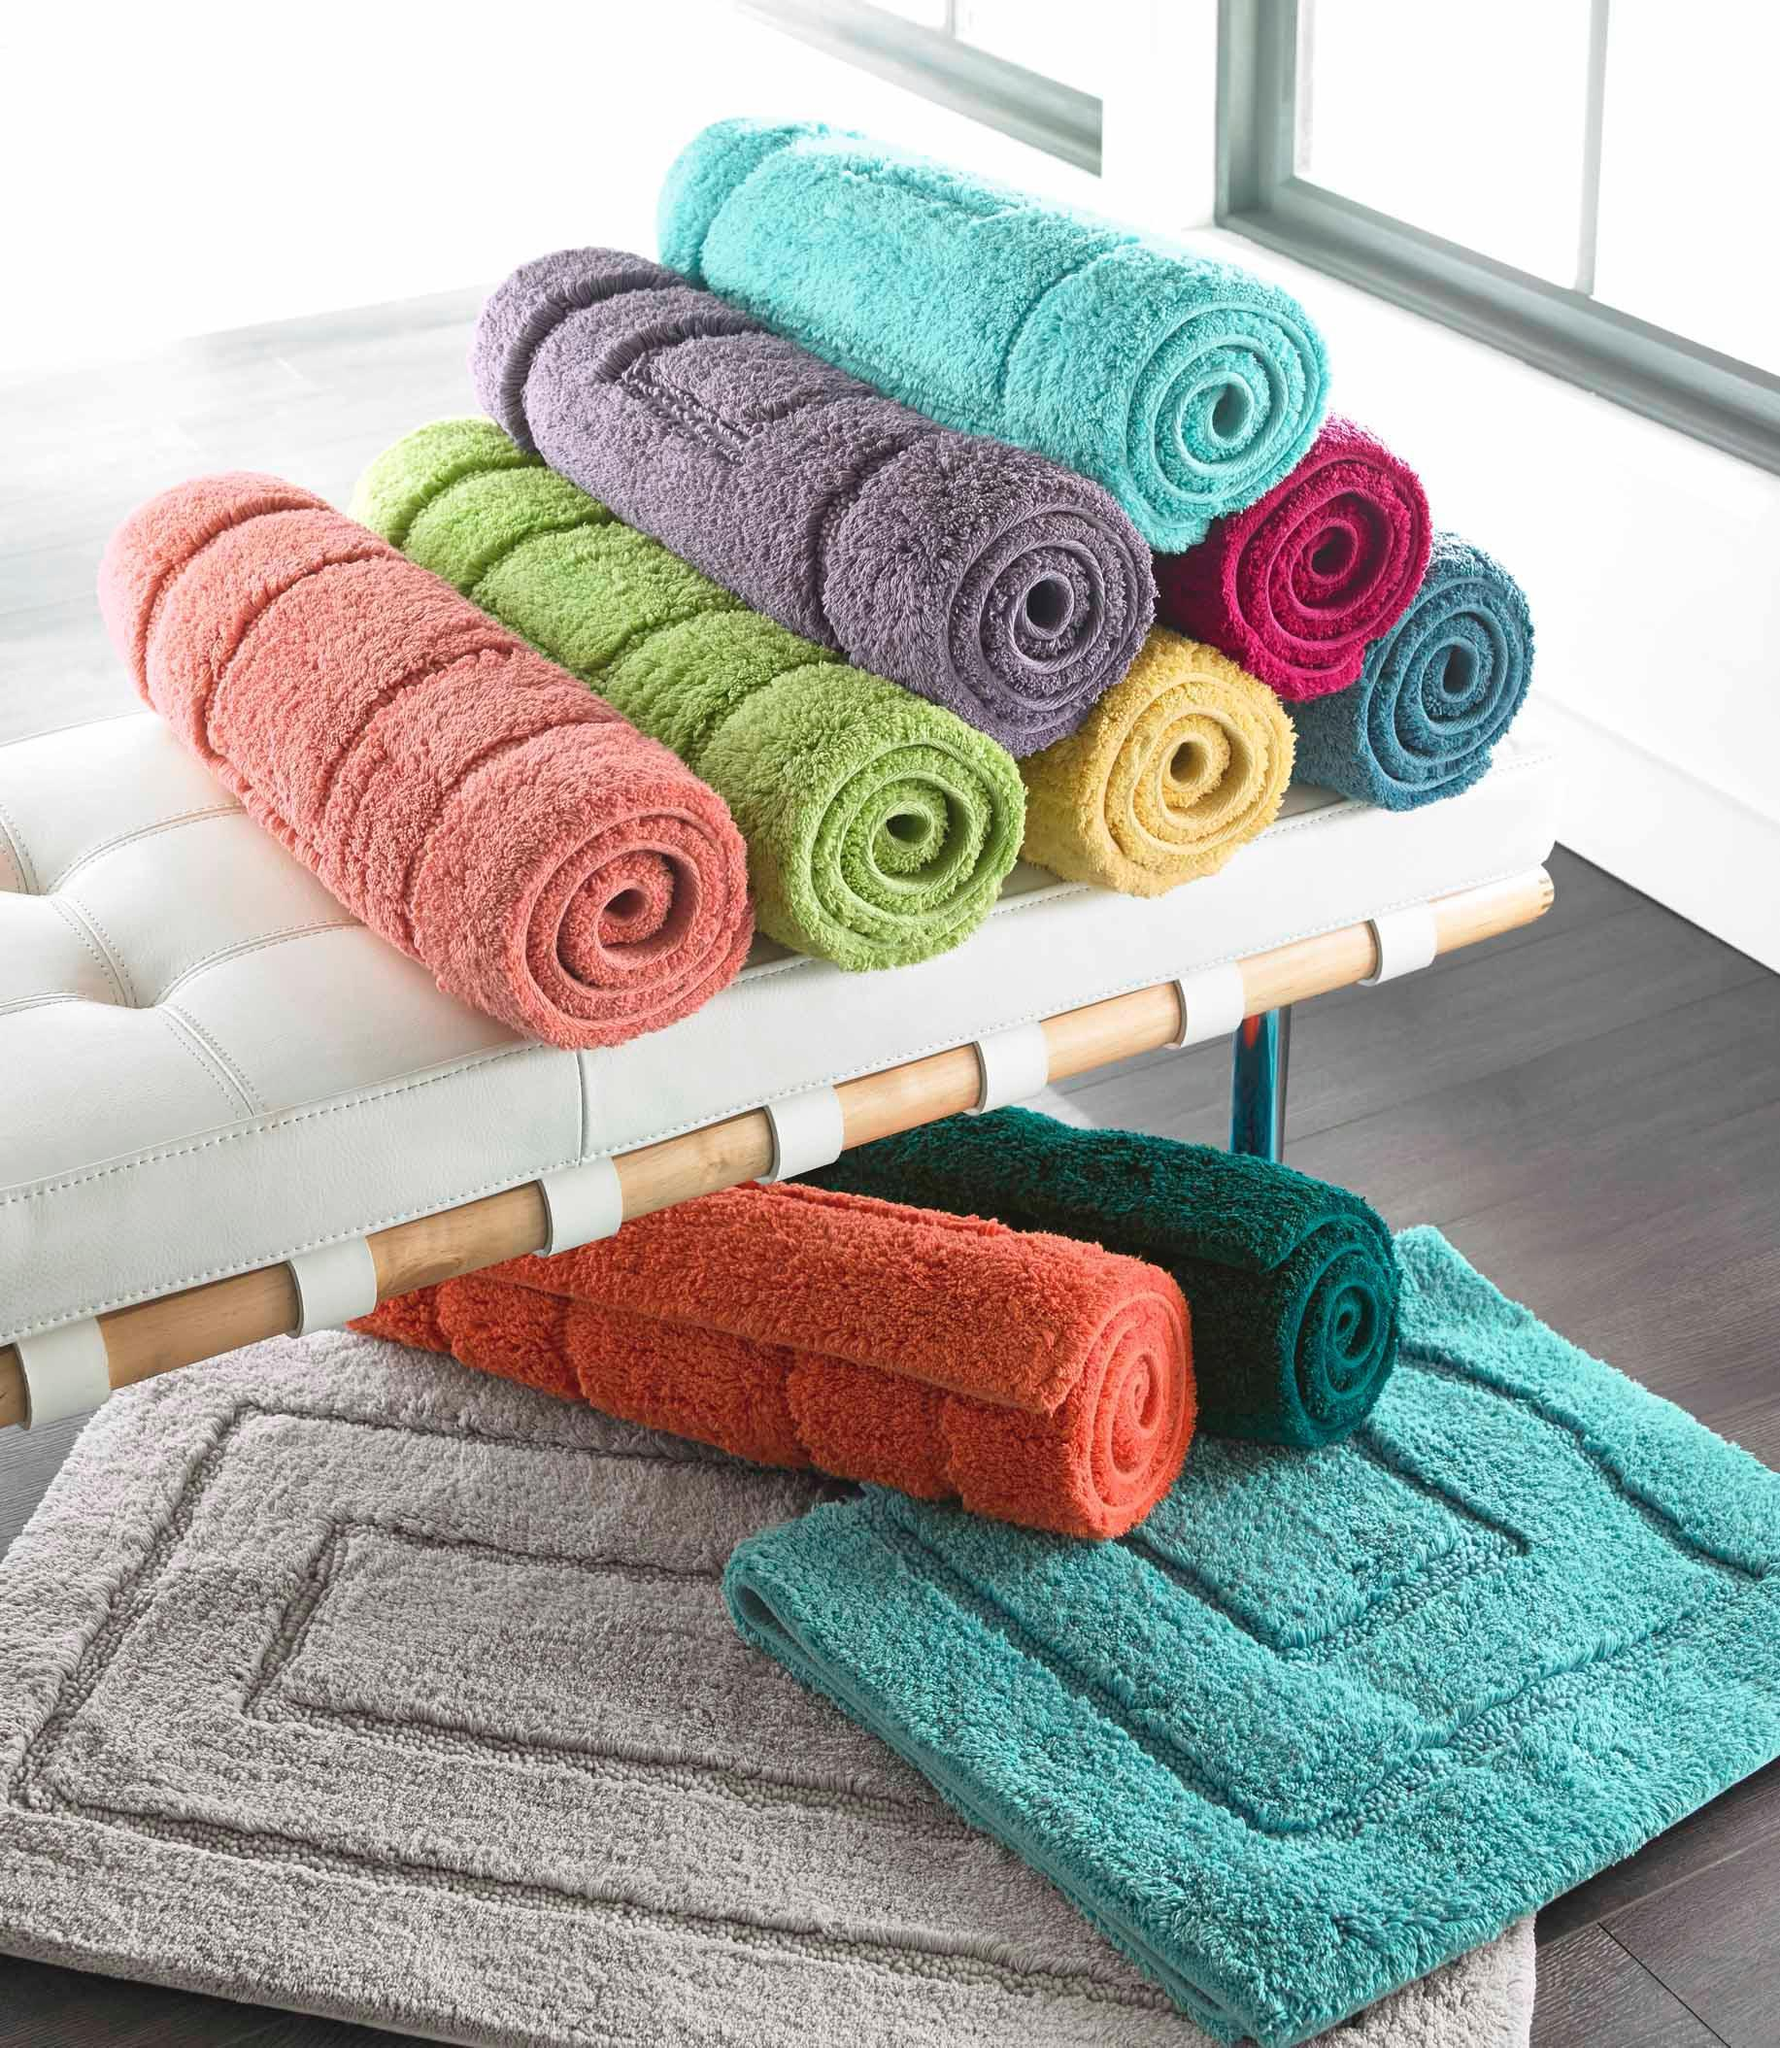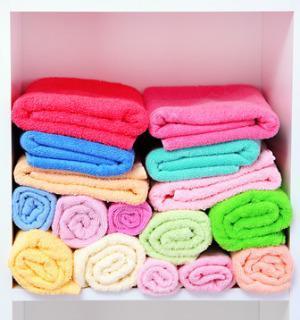The first image is the image on the left, the second image is the image on the right. For the images shown, is this caption "There are exactly five towels in the left image." true? Answer yes or no. No. The first image is the image on the left, the second image is the image on the right. Analyze the images presented: Is the assertion "There is a single tower of five towels." valid? Answer yes or no. No. 